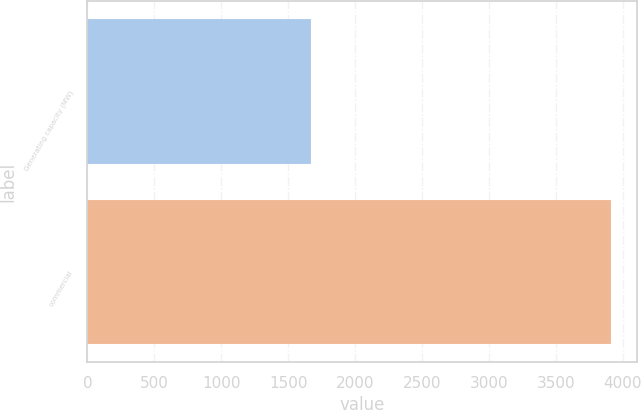Convert chart. <chart><loc_0><loc_0><loc_500><loc_500><bar_chart><fcel>Generating capacity (MW)<fcel>commercial<nl><fcel>1668<fcel>3913<nl></chart> 